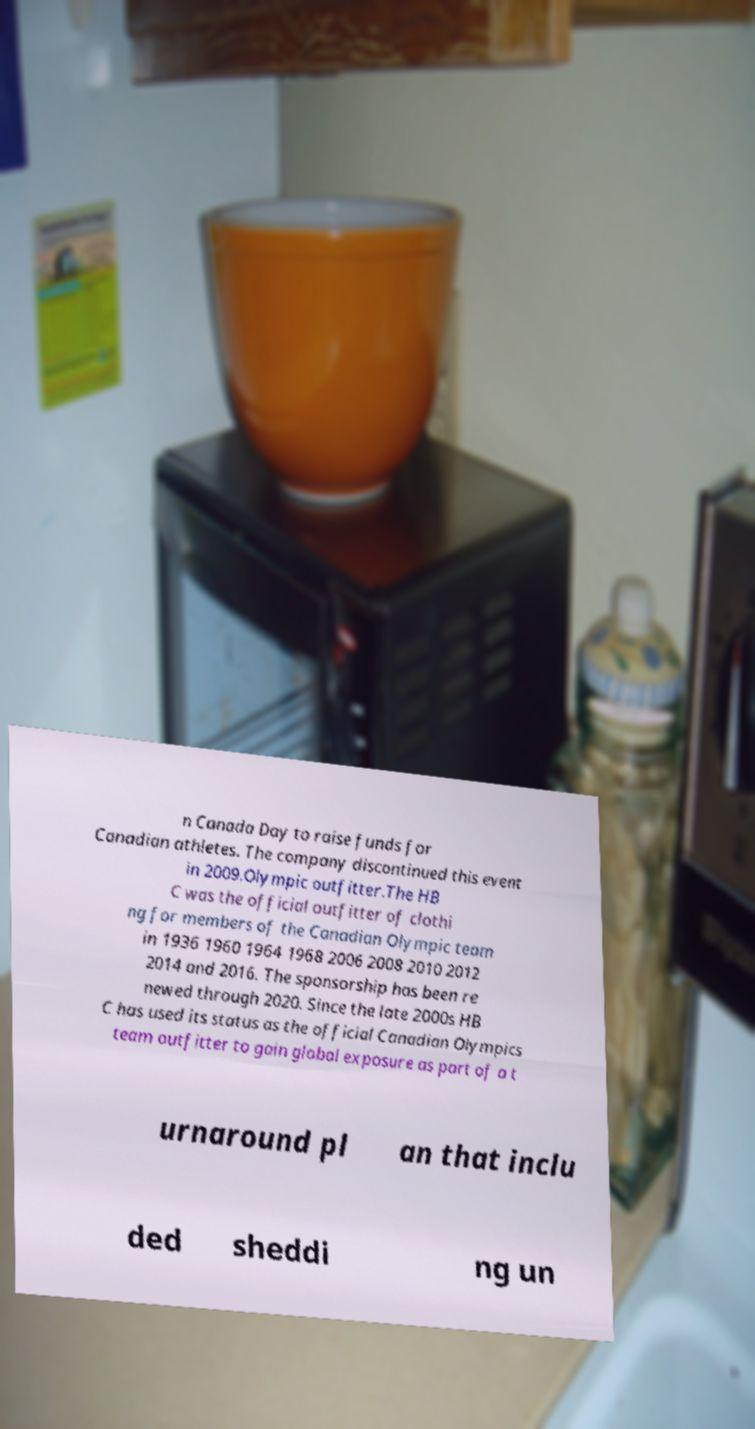There's text embedded in this image that I need extracted. Can you transcribe it verbatim? n Canada Day to raise funds for Canadian athletes. The company discontinued this event in 2009.Olympic outfitter.The HB C was the official outfitter of clothi ng for members of the Canadian Olympic team in 1936 1960 1964 1968 2006 2008 2010 2012 2014 and 2016. The sponsorship has been re newed through 2020. Since the late 2000s HB C has used its status as the official Canadian Olympics team outfitter to gain global exposure as part of a t urnaround pl an that inclu ded sheddi ng un 